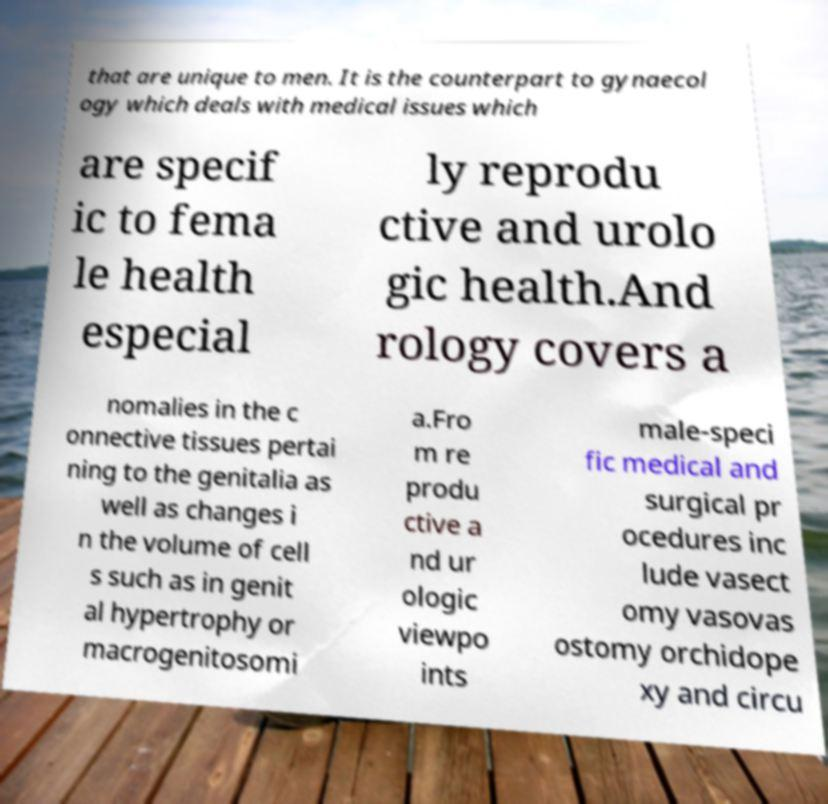Can you accurately transcribe the text from the provided image for me? that are unique to men. It is the counterpart to gynaecol ogy which deals with medical issues which are specif ic to fema le health especial ly reprodu ctive and urolo gic health.And rology covers a nomalies in the c onnective tissues pertai ning to the genitalia as well as changes i n the volume of cell s such as in genit al hypertrophy or macrogenitosomi a.Fro m re produ ctive a nd ur ologic viewpo ints male-speci fic medical and surgical pr ocedures inc lude vasect omy vasovas ostomy orchidope xy and circu 